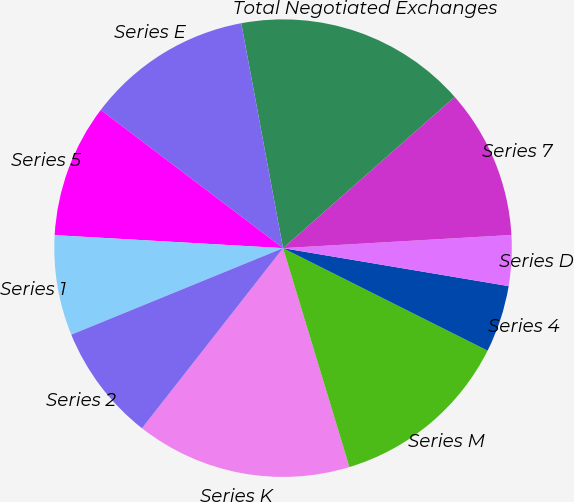Convert chart to OTSL. <chart><loc_0><loc_0><loc_500><loc_500><pie_chart><fcel>Series K<fcel>Series M<fcel>Series 4<fcel>Series D<fcel>Series 7<fcel>Total Negotiated Exchanges<fcel>Series E<fcel>Series 5<fcel>Series 1<fcel>Series 2<nl><fcel>15.26%<fcel>12.92%<fcel>4.74%<fcel>3.57%<fcel>10.58%<fcel>16.43%<fcel>11.75%<fcel>9.42%<fcel>7.08%<fcel>8.25%<nl></chart> 